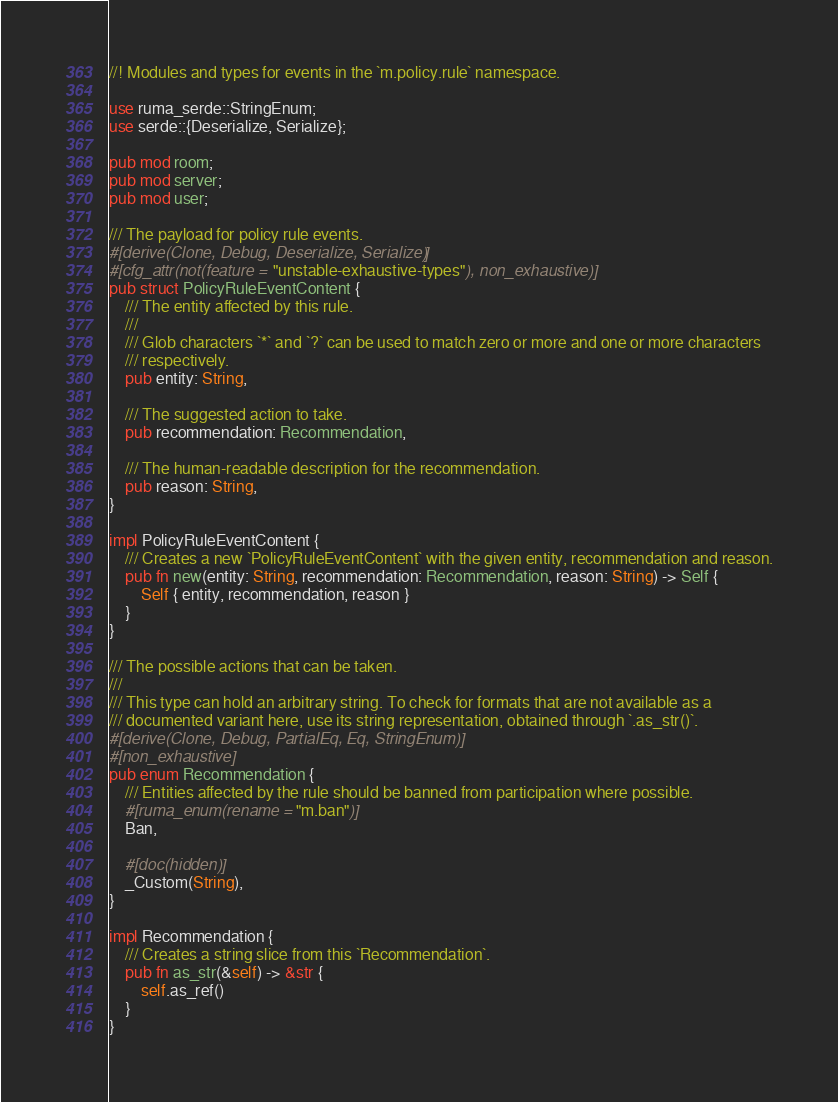<code> <loc_0><loc_0><loc_500><loc_500><_Rust_>//! Modules and types for events in the `m.policy.rule` namespace.

use ruma_serde::StringEnum;
use serde::{Deserialize, Serialize};

pub mod room;
pub mod server;
pub mod user;

/// The payload for policy rule events.
#[derive(Clone, Debug, Deserialize, Serialize)]
#[cfg_attr(not(feature = "unstable-exhaustive-types"), non_exhaustive)]
pub struct PolicyRuleEventContent {
    /// The entity affected by this rule.
    ///
    /// Glob characters `*` and `?` can be used to match zero or more and one or more characters
    /// respectively.
    pub entity: String,

    /// The suggested action to take.
    pub recommendation: Recommendation,

    /// The human-readable description for the recommendation.
    pub reason: String,
}

impl PolicyRuleEventContent {
    /// Creates a new `PolicyRuleEventContent` with the given entity, recommendation and reason.
    pub fn new(entity: String, recommendation: Recommendation, reason: String) -> Self {
        Self { entity, recommendation, reason }
    }
}

/// The possible actions that can be taken.
///
/// This type can hold an arbitrary string. To check for formats that are not available as a
/// documented variant here, use its string representation, obtained through `.as_str()`.
#[derive(Clone, Debug, PartialEq, Eq, StringEnum)]
#[non_exhaustive]
pub enum Recommendation {
    /// Entities affected by the rule should be banned from participation where possible.
    #[ruma_enum(rename = "m.ban")]
    Ban,

    #[doc(hidden)]
    _Custom(String),
}

impl Recommendation {
    /// Creates a string slice from this `Recommendation`.
    pub fn as_str(&self) -> &str {
        self.as_ref()
    }
}
</code> 